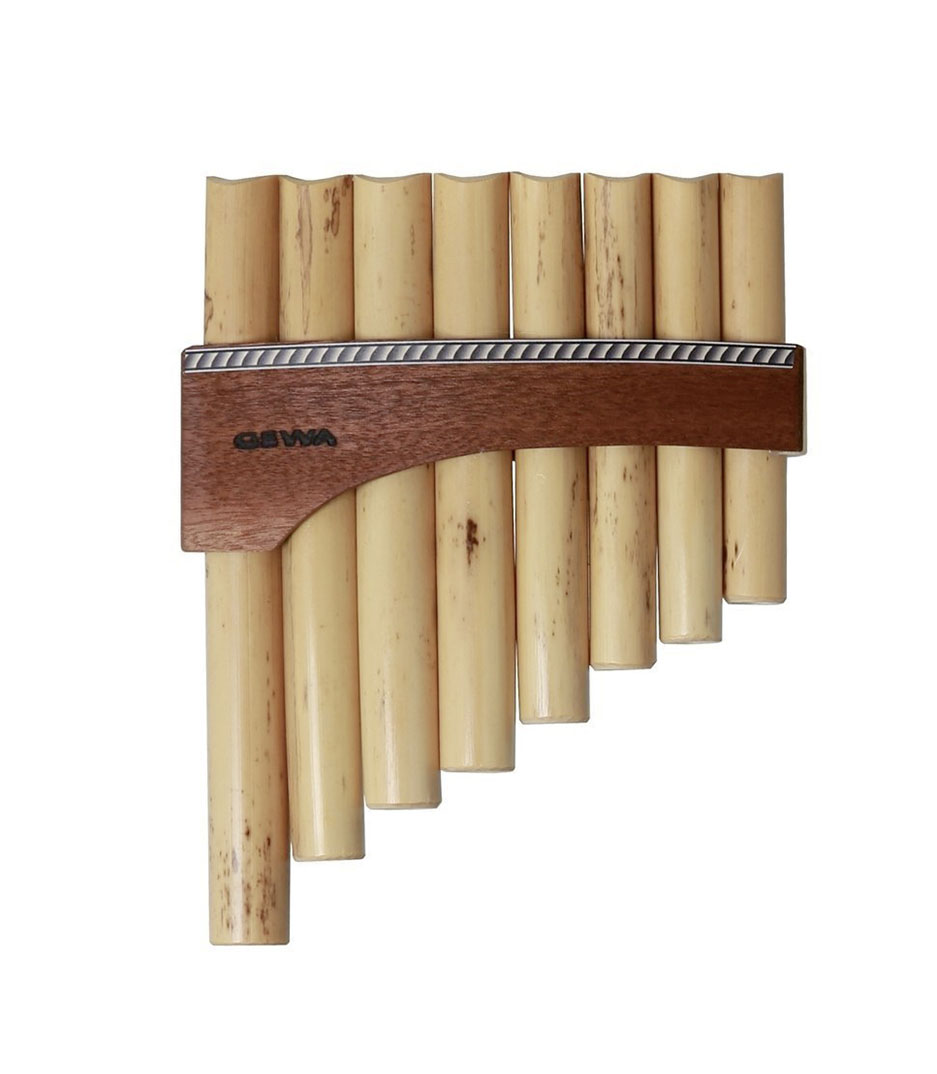How can one learn to play the pan flute? Learning to play the pan flute might initially seem daunting, but with passion and practice, anyone can master it. Start by familiarizing yourself with the instrument, getting to know the feel and layout of the pipes. Breath control is crucial—practice inhaling deeply and exhaling evenly to produce clear notes. Begin with simple scales and melodies, gradually increasing complexity as you become more comfortable. Listening to expert players and watching tutorials can provide insights into techniques and styles. Patience and consistent practice are key, and with time, the enchanting sounds of the pan flute will become second nature. 